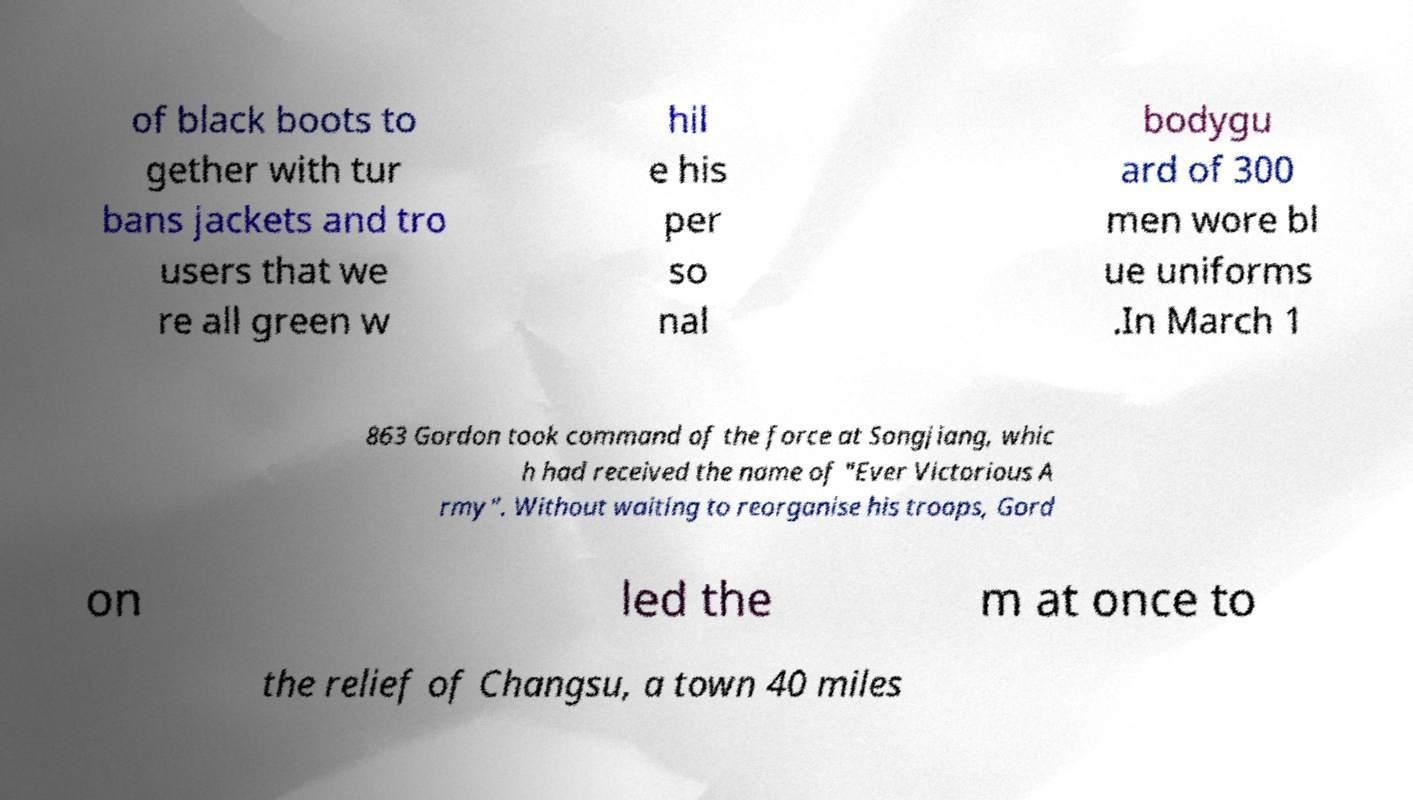Can you read and provide the text displayed in the image?This photo seems to have some interesting text. Can you extract and type it out for me? of black boots to gether with tur bans jackets and tro users that we re all green w hil e his per so nal bodygu ard of 300 men wore bl ue uniforms .In March 1 863 Gordon took command of the force at Songjiang, whic h had received the name of "Ever Victorious A rmy". Without waiting to reorganise his troops, Gord on led the m at once to the relief of Changsu, a town 40 miles 